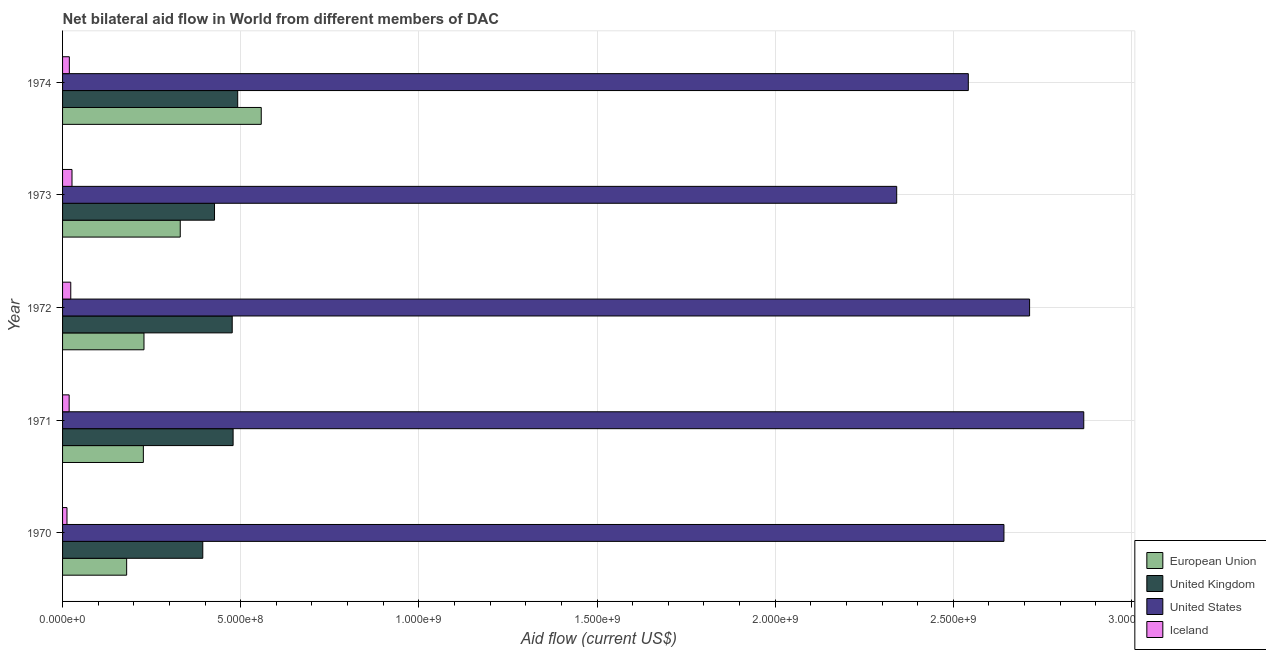How many different coloured bars are there?
Give a very brief answer. 4. Are the number of bars on each tick of the Y-axis equal?
Provide a succinct answer. Yes. How many bars are there on the 5th tick from the bottom?
Provide a short and direct response. 4. What is the label of the 3rd group of bars from the top?
Make the answer very short. 1972. In how many cases, is the number of bars for a given year not equal to the number of legend labels?
Make the answer very short. 0. What is the amount of aid given by iceland in 1970?
Your response must be concise. 1.24e+07. Across all years, what is the maximum amount of aid given by us?
Keep it short and to the point. 2.87e+09. Across all years, what is the minimum amount of aid given by iceland?
Offer a very short reply. 1.24e+07. In which year was the amount of aid given by iceland maximum?
Your answer should be very brief. 1973. What is the total amount of aid given by iceland in the graph?
Your answer should be compact. 9.94e+07. What is the difference between the amount of aid given by uk in 1970 and that in 1974?
Your answer should be very brief. -9.80e+07. What is the difference between the amount of aid given by uk in 1972 and the amount of aid given by iceland in 1970?
Your response must be concise. 4.64e+08. What is the average amount of aid given by eu per year?
Keep it short and to the point. 3.05e+08. In the year 1971, what is the difference between the amount of aid given by us and amount of aid given by eu?
Make the answer very short. 2.64e+09. What is the ratio of the amount of aid given by eu in 1972 to that in 1974?
Give a very brief answer. 0.41. Is the amount of aid given by eu in 1972 less than that in 1973?
Offer a very short reply. Yes. What is the difference between the highest and the second highest amount of aid given by uk?
Offer a terse response. 1.29e+07. What is the difference between the highest and the lowest amount of aid given by iceland?
Offer a terse response. 1.41e+07. Is it the case that in every year, the sum of the amount of aid given by us and amount of aid given by uk is greater than the sum of amount of aid given by eu and amount of aid given by iceland?
Keep it short and to the point. Yes. What does the 1st bar from the top in 1972 represents?
Your answer should be very brief. Iceland. What does the 3rd bar from the bottom in 1972 represents?
Offer a terse response. United States. Is it the case that in every year, the sum of the amount of aid given by eu and amount of aid given by uk is greater than the amount of aid given by us?
Ensure brevity in your answer.  No. How many bars are there?
Offer a terse response. 20. Are all the bars in the graph horizontal?
Provide a succinct answer. Yes. What is the difference between two consecutive major ticks on the X-axis?
Offer a terse response. 5.00e+08. Are the values on the major ticks of X-axis written in scientific E-notation?
Your response must be concise. Yes. Does the graph contain any zero values?
Keep it short and to the point. No. Where does the legend appear in the graph?
Ensure brevity in your answer.  Bottom right. How many legend labels are there?
Make the answer very short. 4. How are the legend labels stacked?
Your answer should be very brief. Vertical. What is the title of the graph?
Your answer should be very brief. Net bilateral aid flow in World from different members of DAC. Does "Bird species" appear as one of the legend labels in the graph?
Provide a succinct answer. No. What is the label or title of the X-axis?
Your answer should be compact. Aid flow (current US$). What is the Aid flow (current US$) of European Union in 1970?
Keep it short and to the point. 1.80e+08. What is the Aid flow (current US$) of United Kingdom in 1970?
Give a very brief answer. 3.94e+08. What is the Aid flow (current US$) of United States in 1970?
Give a very brief answer. 2.64e+09. What is the Aid flow (current US$) in Iceland in 1970?
Your answer should be compact. 1.24e+07. What is the Aid flow (current US$) in European Union in 1971?
Offer a very short reply. 2.27e+08. What is the Aid flow (current US$) of United Kingdom in 1971?
Your answer should be very brief. 4.79e+08. What is the Aid flow (current US$) of United States in 1971?
Give a very brief answer. 2.87e+09. What is the Aid flow (current US$) of Iceland in 1971?
Your answer should be compact. 1.85e+07. What is the Aid flow (current US$) of European Union in 1972?
Your answer should be compact. 2.29e+08. What is the Aid flow (current US$) in United Kingdom in 1972?
Ensure brevity in your answer.  4.76e+08. What is the Aid flow (current US$) of United States in 1972?
Your answer should be very brief. 2.71e+09. What is the Aid flow (current US$) in Iceland in 1972?
Provide a short and direct response. 2.30e+07. What is the Aid flow (current US$) of European Union in 1973?
Keep it short and to the point. 3.30e+08. What is the Aid flow (current US$) in United Kingdom in 1973?
Offer a terse response. 4.26e+08. What is the Aid flow (current US$) of United States in 1973?
Your answer should be very brief. 2.34e+09. What is the Aid flow (current US$) in Iceland in 1973?
Offer a very short reply. 2.65e+07. What is the Aid flow (current US$) of European Union in 1974?
Make the answer very short. 5.58e+08. What is the Aid flow (current US$) of United Kingdom in 1974?
Provide a short and direct response. 4.92e+08. What is the Aid flow (current US$) in United States in 1974?
Provide a short and direct response. 2.54e+09. What is the Aid flow (current US$) of Iceland in 1974?
Provide a succinct answer. 1.90e+07. Across all years, what is the maximum Aid flow (current US$) in European Union?
Make the answer very short. 5.58e+08. Across all years, what is the maximum Aid flow (current US$) of United Kingdom?
Provide a short and direct response. 4.92e+08. Across all years, what is the maximum Aid flow (current US$) of United States?
Ensure brevity in your answer.  2.87e+09. Across all years, what is the maximum Aid flow (current US$) of Iceland?
Offer a terse response. 2.65e+07. Across all years, what is the minimum Aid flow (current US$) of European Union?
Your answer should be compact. 1.80e+08. Across all years, what is the minimum Aid flow (current US$) in United Kingdom?
Keep it short and to the point. 3.94e+08. Across all years, what is the minimum Aid flow (current US$) of United States?
Your answer should be compact. 2.34e+09. Across all years, what is the minimum Aid flow (current US$) in Iceland?
Keep it short and to the point. 1.24e+07. What is the total Aid flow (current US$) of European Union in the graph?
Your answer should be very brief. 1.52e+09. What is the total Aid flow (current US$) in United Kingdom in the graph?
Your answer should be compact. 2.27e+09. What is the total Aid flow (current US$) of United States in the graph?
Your answer should be compact. 1.31e+1. What is the total Aid flow (current US$) of Iceland in the graph?
Your answer should be very brief. 9.94e+07. What is the difference between the Aid flow (current US$) in European Union in 1970 and that in 1971?
Your answer should be very brief. -4.69e+07. What is the difference between the Aid flow (current US$) of United Kingdom in 1970 and that in 1971?
Your answer should be very brief. -8.51e+07. What is the difference between the Aid flow (current US$) in United States in 1970 and that in 1971?
Your answer should be compact. -2.24e+08. What is the difference between the Aid flow (current US$) in Iceland in 1970 and that in 1971?
Provide a succinct answer. -6.11e+06. What is the difference between the Aid flow (current US$) of European Union in 1970 and that in 1972?
Ensure brevity in your answer.  -4.86e+07. What is the difference between the Aid flow (current US$) in United Kingdom in 1970 and that in 1972?
Ensure brevity in your answer.  -8.26e+07. What is the difference between the Aid flow (current US$) of United States in 1970 and that in 1972?
Provide a short and direct response. -7.20e+07. What is the difference between the Aid flow (current US$) in Iceland in 1970 and that in 1972?
Offer a terse response. -1.06e+07. What is the difference between the Aid flow (current US$) of European Union in 1970 and that in 1973?
Provide a succinct answer. -1.50e+08. What is the difference between the Aid flow (current US$) in United Kingdom in 1970 and that in 1973?
Your response must be concise. -3.30e+07. What is the difference between the Aid flow (current US$) of United States in 1970 and that in 1973?
Your answer should be compact. 3.01e+08. What is the difference between the Aid flow (current US$) in Iceland in 1970 and that in 1973?
Ensure brevity in your answer.  -1.41e+07. What is the difference between the Aid flow (current US$) in European Union in 1970 and that in 1974?
Keep it short and to the point. -3.78e+08. What is the difference between the Aid flow (current US$) of United Kingdom in 1970 and that in 1974?
Give a very brief answer. -9.80e+07. What is the difference between the Aid flow (current US$) in Iceland in 1970 and that in 1974?
Give a very brief answer. -6.65e+06. What is the difference between the Aid flow (current US$) in European Union in 1971 and that in 1972?
Give a very brief answer. -1.74e+06. What is the difference between the Aid flow (current US$) of United Kingdom in 1971 and that in 1972?
Ensure brevity in your answer.  2.50e+06. What is the difference between the Aid flow (current US$) in United States in 1971 and that in 1972?
Your response must be concise. 1.52e+08. What is the difference between the Aid flow (current US$) of Iceland in 1971 and that in 1972?
Make the answer very short. -4.51e+06. What is the difference between the Aid flow (current US$) in European Union in 1971 and that in 1973?
Keep it short and to the point. -1.04e+08. What is the difference between the Aid flow (current US$) of United Kingdom in 1971 and that in 1973?
Offer a terse response. 5.22e+07. What is the difference between the Aid flow (current US$) in United States in 1971 and that in 1973?
Your response must be concise. 5.25e+08. What is the difference between the Aid flow (current US$) of Iceland in 1971 and that in 1973?
Your response must be concise. -7.99e+06. What is the difference between the Aid flow (current US$) of European Union in 1971 and that in 1974?
Make the answer very short. -3.31e+08. What is the difference between the Aid flow (current US$) in United Kingdom in 1971 and that in 1974?
Ensure brevity in your answer.  -1.29e+07. What is the difference between the Aid flow (current US$) of United States in 1971 and that in 1974?
Offer a very short reply. 3.24e+08. What is the difference between the Aid flow (current US$) of Iceland in 1971 and that in 1974?
Your answer should be very brief. -5.40e+05. What is the difference between the Aid flow (current US$) in European Union in 1972 and that in 1973?
Your response must be concise. -1.02e+08. What is the difference between the Aid flow (current US$) of United Kingdom in 1972 and that in 1973?
Your answer should be compact. 4.97e+07. What is the difference between the Aid flow (current US$) in United States in 1972 and that in 1973?
Provide a short and direct response. 3.73e+08. What is the difference between the Aid flow (current US$) in Iceland in 1972 and that in 1973?
Offer a very short reply. -3.48e+06. What is the difference between the Aid flow (current US$) in European Union in 1972 and that in 1974?
Keep it short and to the point. -3.29e+08. What is the difference between the Aid flow (current US$) of United Kingdom in 1972 and that in 1974?
Make the answer very short. -1.54e+07. What is the difference between the Aid flow (current US$) in United States in 1972 and that in 1974?
Provide a short and direct response. 1.72e+08. What is the difference between the Aid flow (current US$) of Iceland in 1972 and that in 1974?
Keep it short and to the point. 3.97e+06. What is the difference between the Aid flow (current US$) in European Union in 1973 and that in 1974?
Offer a terse response. -2.27e+08. What is the difference between the Aid flow (current US$) of United Kingdom in 1973 and that in 1974?
Your answer should be compact. -6.50e+07. What is the difference between the Aid flow (current US$) of United States in 1973 and that in 1974?
Provide a short and direct response. -2.01e+08. What is the difference between the Aid flow (current US$) of Iceland in 1973 and that in 1974?
Your answer should be very brief. 7.45e+06. What is the difference between the Aid flow (current US$) of European Union in 1970 and the Aid flow (current US$) of United Kingdom in 1971?
Provide a succinct answer. -2.99e+08. What is the difference between the Aid flow (current US$) in European Union in 1970 and the Aid flow (current US$) in United States in 1971?
Provide a succinct answer. -2.69e+09. What is the difference between the Aid flow (current US$) of European Union in 1970 and the Aid flow (current US$) of Iceland in 1971?
Make the answer very short. 1.61e+08. What is the difference between the Aid flow (current US$) of United Kingdom in 1970 and the Aid flow (current US$) of United States in 1971?
Ensure brevity in your answer.  -2.47e+09. What is the difference between the Aid flow (current US$) of United Kingdom in 1970 and the Aid flow (current US$) of Iceland in 1971?
Provide a short and direct response. 3.75e+08. What is the difference between the Aid flow (current US$) in United States in 1970 and the Aid flow (current US$) in Iceland in 1971?
Provide a short and direct response. 2.62e+09. What is the difference between the Aid flow (current US$) in European Union in 1970 and the Aid flow (current US$) in United Kingdom in 1972?
Your answer should be very brief. -2.96e+08. What is the difference between the Aid flow (current US$) in European Union in 1970 and the Aid flow (current US$) in United States in 1972?
Keep it short and to the point. -2.53e+09. What is the difference between the Aid flow (current US$) in European Union in 1970 and the Aid flow (current US$) in Iceland in 1972?
Your answer should be very brief. 1.57e+08. What is the difference between the Aid flow (current US$) of United Kingdom in 1970 and the Aid flow (current US$) of United States in 1972?
Ensure brevity in your answer.  -2.32e+09. What is the difference between the Aid flow (current US$) in United Kingdom in 1970 and the Aid flow (current US$) in Iceland in 1972?
Provide a short and direct response. 3.70e+08. What is the difference between the Aid flow (current US$) in United States in 1970 and the Aid flow (current US$) in Iceland in 1972?
Your answer should be compact. 2.62e+09. What is the difference between the Aid flow (current US$) in European Union in 1970 and the Aid flow (current US$) in United Kingdom in 1973?
Keep it short and to the point. -2.47e+08. What is the difference between the Aid flow (current US$) in European Union in 1970 and the Aid flow (current US$) in United States in 1973?
Your answer should be very brief. -2.16e+09. What is the difference between the Aid flow (current US$) in European Union in 1970 and the Aid flow (current US$) in Iceland in 1973?
Your answer should be very brief. 1.53e+08. What is the difference between the Aid flow (current US$) of United Kingdom in 1970 and the Aid flow (current US$) of United States in 1973?
Provide a succinct answer. -1.95e+09. What is the difference between the Aid flow (current US$) in United Kingdom in 1970 and the Aid flow (current US$) in Iceland in 1973?
Provide a short and direct response. 3.67e+08. What is the difference between the Aid flow (current US$) of United States in 1970 and the Aid flow (current US$) of Iceland in 1973?
Provide a short and direct response. 2.62e+09. What is the difference between the Aid flow (current US$) in European Union in 1970 and the Aid flow (current US$) in United Kingdom in 1974?
Provide a short and direct response. -3.12e+08. What is the difference between the Aid flow (current US$) in European Union in 1970 and the Aid flow (current US$) in United States in 1974?
Your answer should be compact. -2.36e+09. What is the difference between the Aid flow (current US$) in European Union in 1970 and the Aid flow (current US$) in Iceland in 1974?
Your response must be concise. 1.61e+08. What is the difference between the Aid flow (current US$) in United Kingdom in 1970 and the Aid flow (current US$) in United States in 1974?
Your answer should be very brief. -2.15e+09. What is the difference between the Aid flow (current US$) in United Kingdom in 1970 and the Aid flow (current US$) in Iceland in 1974?
Your answer should be compact. 3.74e+08. What is the difference between the Aid flow (current US$) of United States in 1970 and the Aid flow (current US$) of Iceland in 1974?
Your response must be concise. 2.62e+09. What is the difference between the Aid flow (current US$) of European Union in 1971 and the Aid flow (current US$) of United Kingdom in 1972?
Keep it short and to the point. -2.49e+08. What is the difference between the Aid flow (current US$) of European Union in 1971 and the Aid flow (current US$) of United States in 1972?
Give a very brief answer. -2.49e+09. What is the difference between the Aid flow (current US$) of European Union in 1971 and the Aid flow (current US$) of Iceland in 1972?
Your answer should be compact. 2.04e+08. What is the difference between the Aid flow (current US$) of United Kingdom in 1971 and the Aid flow (current US$) of United States in 1972?
Make the answer very short. -2.24e+09. What is the difference between the Aid flow (current US$) of United Kingdom in 1971 and the Aid flow (current US$) of Iceland in 1972?
Ensure brevity in your answer.  4.56e+08. What is the difference between the Aid flow (current US$) of United States in 1971 and the Aid flow (current US$) of Iceland in 1972?
Offer a terse response. 2.84e+09. What is the difference between the Aid flow (current US$) of European Union in 1971 and the Aid flow (current US$) of United Kingdom in 1973?
Keep it short and to the point. -2.00e+08. What is the difference between the Aid flow (current US$) in European Union in 1971 and the Aid flow (current US$) in United States in 1973?
Make the answer very short. -2.11e+09. What is the difference between the Aid flow (current US$) in European Union in 1971 and the Aid flow (current US$) in Iceland in 1973?
Make the answer very short. 2.00e+08. What is the difference between the Aid flow (current US$) of United Kingdom in 1971 and the Aid flow (current US$) of United States in 1973?
Provide a succinct answer. -1.86e+09. What is the difference between the Aid flow (current US$) in United Kingdom in 1971 and the Aid flow (current US$) in Iceland in 1973?
Keep it short and to the point. 4.52e+08. What is the difference between the Aid flow (current US$) of United States in 1971 and the Aid flow (current US$) of Iceland in 1973?
Keep it short and to the point. 2.84e+09. What is the difference between the Aid flow (current US$) in European Union in 1971 and the Aid flow (current US$) in United Kingdom in 1974?
Your response must be concise. -2.65e+08. What is the difference between the Aid flow (current US$) of European Union in 1971 and the Aid flow (current US$) of United States in 1974?
Give a very brief answer. -2.32e+09. What is the difference between the Aid flow (current US$) in European Union in 1971 and the Aid flow (current US$) in Iceland in 1974?
Provide a short and direct response. 2.08e+08. What is the difference between the Aid flow (current US$) of United Kingdom in 1971 and the Aid flow (current US$) of United States in 1974?
Your answer should be compact. -2.06e+09. What is the difference between the Aid flow (current US$) in United Kingdom in 1971 and the Aid flow (current US$) in Iceland in 1974?
Give a very brief answer. 4.60e+08. What is the difference between the Aid flow (current US$) in United States in 1971 and the Aid flow (current US$) in Iceland in 1974?
Give a very brief answer. 2.85e+09. What is the difference between the Aid flow (current US$) of European Union in 1972 and the Aid flow (current US$) of United Kingdom in 1973?
Your response must be concise. -1.98e+08. What is the difference between the Aid flow (current US$) in European Union in 1972 and the Aid flow (current US$) in United States in 1973?
Ensure brevity in your answer.  -2.11e+09. What is the difference between the Aid flow (current US$) of European Union in 1972 and the Aid flow (current US$) of Iceland in 1973?
Give a very brief answer. 2.02e+08. What is the difference between the Aid flow (current US$) of United Kingdom in 1972 and the Aid flow (current US$) of United States in 1973?
Offer a very short reply. -1.86e+09. What is the difference between the Aid flow (current US$) of United Kingdom in 1972 and the Aid flow (current US$) of Iceland in 1973?
Your answer should be compact. 4.50e+08. What is the difference between the Aid flow (current US$) of United States in 1972 and the Aid flow (current US$) of Iceland in 1973?
Offer a very short reply. 2.69e+09. What is the difference between the Aid flow (current US$) of European Union in 1972 and the Aid flow (current US$) of United Kingdom in 1974?
Ensure brevity in your answer.  -2.63e+08. What is the difference between the Aid flow (current US$) in European Union in 1972 and the Aid flow (current US$) in United States in 1974?
Provide a succinct answer. -2.31e+09. What is the difference between the Aid flow (current US$) in European Union in 1972 and the Aid flow (current US$) in Iceland in 1974?
Your answer should be compact. 2.09e+08. What is the difference between the Aid flow (current US$) of United Kingdom in 1972 and the Aid flow (current US$) of United States in 1974?
Offer a terse response. -2.07e+09. What is the difference between the Aid flow (current US$) in United Kingdom in 1972 and the Aid flow (current US$) in Iceland in 1974?
Your answer should be very brief. 4.57e+08. What is the difference between the Aid flow (current US$) of United States in 1972 and the Aid flow (current US$) of Iceland in 1974?
Offer a very short reply. 2.69e+09. What is the difference between the Aid flow (current US$) in European Union in 1973 and the Aid flow (current US$) in United Kingdom in 1974?
Your answer should be very brief. -1.61e+08. What is the difference between the Aid flow (current US$) of European Union in 1973 and the Aid flow (current US$) of United States in 1974?
Make the answer very short. -2.21e+09. What is the difference between the Aid flow (current US$) in European Union in 1973 and the Aid flow (current US$) in Iceland in 1974?
Offer a very short reply. 3.11e+08. What is the difference between the Aid flow (current US$) of United Kingdom in 1973 and the Aid flow (current US$) of United States in 1974?
Make the answer very short. -2.12e+09. What is the difference between the Aid flow (current US$) of United Kingdom in 1973 and the Aid flow (current US$) of Iceland in 1974?
Make the answer very short. 4.07e+08. What is the difference between the Aid flow (current US$) of United States in 1973 and the Aid flow (current US$) of Iceland in 1974?
Keep it short and to the point. 2.32e+09. What is the average Aid flow (current US$) of European Union per year?
Your answer should be very brief. 3.05e+08. What is the average Aid flow (current US$) in United Kingdom per year?
Your answer should be compact. 4.53e+08. What is the average Aid flow (current US$) of United States per year?
Your response must be concise. 2.62e+09. What is the average Aid flow (current US$) of Iceland per year?
Provide a succinct answer. 1.99e+07. In the year 1970, what is the difference between the Aid flow (current US$) of European Union and Aid flow (current US$) of United Kingdom?
Your answer should be very brief. -2.14e+08. In the year 1970, what is the difference between the Aid flow (current US$) of European Union and Aid flow (current US$) of United States?
Your answer should be compact. -2.46e+09. In the year 1970, what is the difference between the Aid flow (current US$) in European Union and Aid flow (current US$) in Iceland?
Ensure brevity in your answer.  1.67e+08. In the year 1970, what is the difference between the Aid flow (current US$) in United Kingdom and Aid flow (current US$) in United States?
Provide a short and direct response. -2.25e+09. In the year 1970, what is the difference between the Aid flow (current US$) of United Kingdom and Aid flow (current US$) of Iceland?
Make the answer very short. 3.81e+08. In the year 1970, what is the difference between the Aid flow (current US$) of United States and Aid flow (current US$) of Iceland?
Keep it short and to the point. 2.63e+09. In the year 1971, what is the difference between the Aid flow (current US$) of European Union and Aid flow (current US$) of United Kingdom?
Give a very brief answer. -2.52e+08. In the year 1971, what is the difference between the Aid flow (current US$) in European Union and Aid flow (current US$) in United States?
Your response must be concise. -2.64e+09. In the year 1971, what is the difference between the Aid flow (current US$) of European Union and Aid flow (current US$) of Iceland?
Keep it short and to the point. 2.08e+08. In the year 1971, what is the difference between the Aid flow (current US$) in United Kingdom and Aid flow (current US$) in United States?
Offer a terse response. -2.39e+09. In the year 1971, what is the difference between the Aid flow (current US$) of United Kingdom and Aid flow (current US$) of Iceland?
Ensure brevity in your answer.  4.60e+08. In the year 1971, what is the difference between the Aid flow (current US$) in United States and Aid flow (current US$) in Iceland?
Provide a short and direct response. 2.85e+09. In the year 1972, what is the difference between the Aid flow (current US$) of European Union and Aid flow (current US$) of United Kingdom?
Provide a short and direct response. -2.48e+08. In the year 1972, what is the difference between the Aid flow (current US$) in European Union and Aid flow (current US$) in United States?
Your answer should be very brief. -2.49e+09. In the year 1972, what is the difference between the Aid flow (current US$) in European Union and Aid flow (current US$) in Iceland?
Your answer should be compact. 2.06e+08. In the year 1972, what is the difference between the Aid flow (current US$) in United Kingdom and Aid flow (current US$) in United States?
Your answer should be compact. -2.24e+09. In the year 1972, what is the difference between the Aid flow (current US$) in United Kingdom and Aid flow (current US$) in Iceland?
Give a very brief answer. 4.53e+08. In the year 1972, what is the difference between the Aid flow (current US$) of United States and Aid flow (current US$) of Iceland?
Provide a succinct answer. 2.69e+09. In the year 1973, what is the difference between the Aid flow (current US$) in European Union and Aid flow (current US$) in United Kingdom?
Your answer should be very brief. -9.62e+07. In the year 1973, what is the difference between the Aid flow (current US$) of European Union and Aid flow (current US$) of United States?
Provide a succinct answer. -2.01e+09. In the year 1973, what is the difference between the Aid flow (current US$) of European Union and Aid flow (current US$) of Iceland?
Your answer should be compact. 3.04e+08. In the year 1973, what is the difference between the Aid flow (current US$) in United Kingdom and Aid flow (current US$) in United States?
Your answer should be very brief. -1.91e+09. In the year 1973, what is the difference between the Aid flow (current US$) in United Kingdom and Aid flow (current US$) in Iceland?
Offer a very short reply. 4.00e+08. In the year 1973, what is the difference between the Aid flow (current US$) of United States and Aid flow (current US$) of Iceland?
Make the answer very short. 2.31e+09. In the year 1974, what is the difference between the Aid flow (current US$) in European Union and Aid flow (current US$) in United Kingdom?
Your answer should be compact. 6.61e+07. In the year 1974, what is the difference between the Aid flow (current US$) of European Union and Aid flow (current US$) of United States?
Your response must be concise. -1.98e+09. In the year 1974, what is the difference between the Aid flow (current US$) in European Union and Aid flow (current US$) in Iceland?
Provide a short and direct response. 5.39e+08. In the year 1974, what is the difference between the Aid flow (current US$) of United Kingdom and Aid flow (current US$) of United States?
Keep it short and to the point. -2.05e+09. In the year 1974, what is the difference between the Aid flow (current US$) of United Kingdom and Aid flow (current US$) of Iceland?
Provide a short and direct response. 4.72e+08. In the year 1974, what is the difference between the Aid flow (current US$) in United States and Aid flow (current US$) in Iceland?
Offer a terse response. 2.52e+09. What is the ratio of the Aid flow (current US$) of European Union in 1970 to that in 1971?
Your answer should be compact. 0.79. What is the ratio of the Aid flow (current US$) in United Kingdom in 1970 to that in 1971?
Ensure brevity in your answer.  0.82. What is the ratio of the Aid flow (current US$) of United States in 1970 to that in 1971?
Your response must be concise. 0.92. What is the ratio of the Aid flow (current US$) in Iceland in 1970 to that in 1971?
Your answer should be very brief. 0.67. What is the ratio of the Aid flow (current US$) of European Union in 1970 to that in 1972?
Your answer should be very brief. 0.79. What is the ratio of the Aid flow (current US$) of United Kingdom in 1970 to that in 1972?
Provide a short and direct response. 0.83. What is the ratio of the Aid flow (current US$) of United States in 1970 to that in 1972?
Your response must be concise. 0.97. What is the ratio of the Aid flow (current US$) in Iceland in 1970 to that in 1972?
Your response must be concise. 0.54. What is the ratio of the Aid flow (current US$) in European Union in 1970 to that in 1973?
Ensure brevity in your answer.  0.54. What is the ratio of the Aid flow (current US$) in United Kingdom in 1970 to that in 1973?
Provide a succinct answer. 0.92. What is the ratio of the Aid flow (current US$) in United States in 1970 to that in 1973?
Provide a succinct answer. 1.13. What is the ratio of the Aid flow (current US$) in Iceland in 1970 to that in 1973?
Keep it short and to the point. 0.47. What is the ratio of the Aid flow (current US$) of European Union in 1970 to that in 1974?
Provide a short and direct response. 0.32. What is the ratio of the Aid flow (current US$) of United Kingdom in 1970 to that in 1974?
Provide a short and direct response. 0.8. What is the ratio of the Aid flow (current US$) in United States in 1970 to that in 1974?
Your response must be concise. 1.04. What is the ratio of the Aid flow (current US$) of Iceland in 1970 to that in 1974?
Your answer should be very brief. 0.65. What is the ratio of the Aid flow (current US$) in European Union in 1971 to that in 1972?
Offer a terse response. 0.99. What is the ratio of the Aid flow (current US$) in United States in 1971 to that in 1972?
Give a very brief answer. 1.06. What is the ratio of the Aid flow (current US$) of Iceland in 1971 to that in 1972?
Offer a very short reply. 0.8. What is the ratio of the Aid flow (current US$) of European Union in 1971 to that in 1973?
Offer a very short reply. 0.69. What is the ratio of the Aid flow (current US$) in United Kingdom in 1971 to that in 1973?
Make the answer very short. 1.12. What is the ratio of the Aid flow (current US$) of United States in 1971 to that in 1973?
Your answer should be compact. 1.22. What is the ratio of the Aid flow (current US$) of Iceland in 1971 to that in 1973?
Provide a succinct answer. 0.7. What is the ratio of the Aid flow (current US$) in European Union in 1971 to that in 1974?
Make the answer very short. 0.41. What is the ratio of the Aid flow (current US$) of United Kingdom in 1971 to that in 1974?
Your response must be concise. 0.97. What is the ratio of the Aid flow (current US$) of United States in 1971 to that in 1974?
Your answer should be very brief. 1.13. What is the ratio of the Aid flow (current US$) of Iceland in 1971 to that in 1974?
Your answer should be compact. 0.97. What is the ratio of the Aid flow (current US$) of European Union in 1972 to that in 1973?
Offer a terse response. 0.69. What is the ratio of the Aid flow (current US$) in United Kingdom in 1972 to that in 1973?
Offer a very short reply. 1.12. What is the ratio of the Aid flow (current US$) in United States in 1972 to that in 1973?
Make the answer very short. 1.16. What is the ratio of the Aid flow (current US$) in Iceland in 1972 to that in 1973?
Your answer should be compact. 0.87. What is the ratio of the Aid flow (current US$) of European Union in 1972 to that in 1974?
Your answer should be very brief. 0.41. What is the ratio of the Aid flow (current US$) of United Kingdom in 1972 to that in 1974?
Your response must be concise. 0.97. What is the ratio of the Aid flow (current US$) in United States in 1972 to that in 1974?
Offer a very short reply. 1.07. What is the ratio of the Aid flow (current US$) of Iceland in 1972 to that in 1974?
Provide a succinct answer. 1.21. What is the ratio of the Aid flow (current US$) of European Union in 1973 to that in 1974?
Give a very brief answer. 0.59. What is the ratio of the Aid flow (current US$) in United Kingdom in 1973 to that in 1974?
Provide a short and direct response. 0.87. What is the ratio of the Aid flow (current US$) in United States in 1973 to that in 1974?
Offer a very short reply. 0.92. What is the ratio of the Aid flow (current US$) of Iceland in 1973 to that in 1974?
Provide a succinct answer. 1.39. What is the difference between the highest and the second highest Aid flow (current US$) in European Union?
Offer a very short reply. 2.27e+08. What is the difference between the highest and the second highest Aid flow (current US$) in United Kingdom?
Keep it short and to the point. 1.29e+07. What is the difference between the highest and the second highest Aid flow (current US$) of United States?
Make the answer very short. 1.52e+08. What is the difference between the highest and the second highest Aid flow (current US$) in Iceland?
Keep it short and to the point. 3.48e+06. What is the difference between the highest and the lowest Aid flow (current US$) in European Union?
Make the answer very short. 3.78e+08. What is the difference between the highest and the lowest Aid flow (current US$) in United Kingdom?
Give a very brief answer. 9.80e+07. What is the difference between the highest and the lowest Aid flow (current US$) in United States?
Give a very brief answer. 5.25e+08. What is the difference between the highest and the lowest Aid flow (current US$) of Iceland?
Offer a terse response. 1.41e+07. 